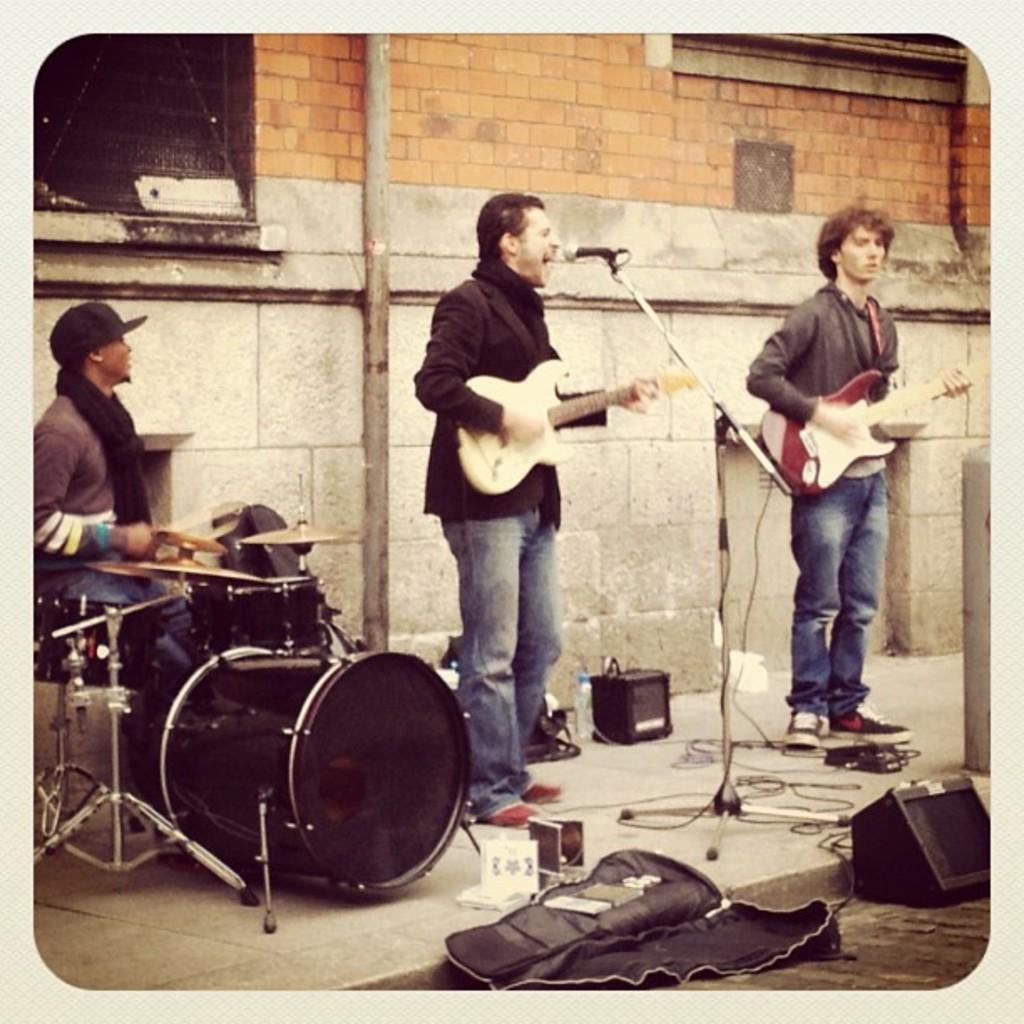How would you summarize this image in a sentence or two? In this image I can see three people standing on the path and playing the musical instruments. Among them few are wearing jackets and one person is standing in front of the mic. In the back there's a wall. And some objects can be seen on the road. 